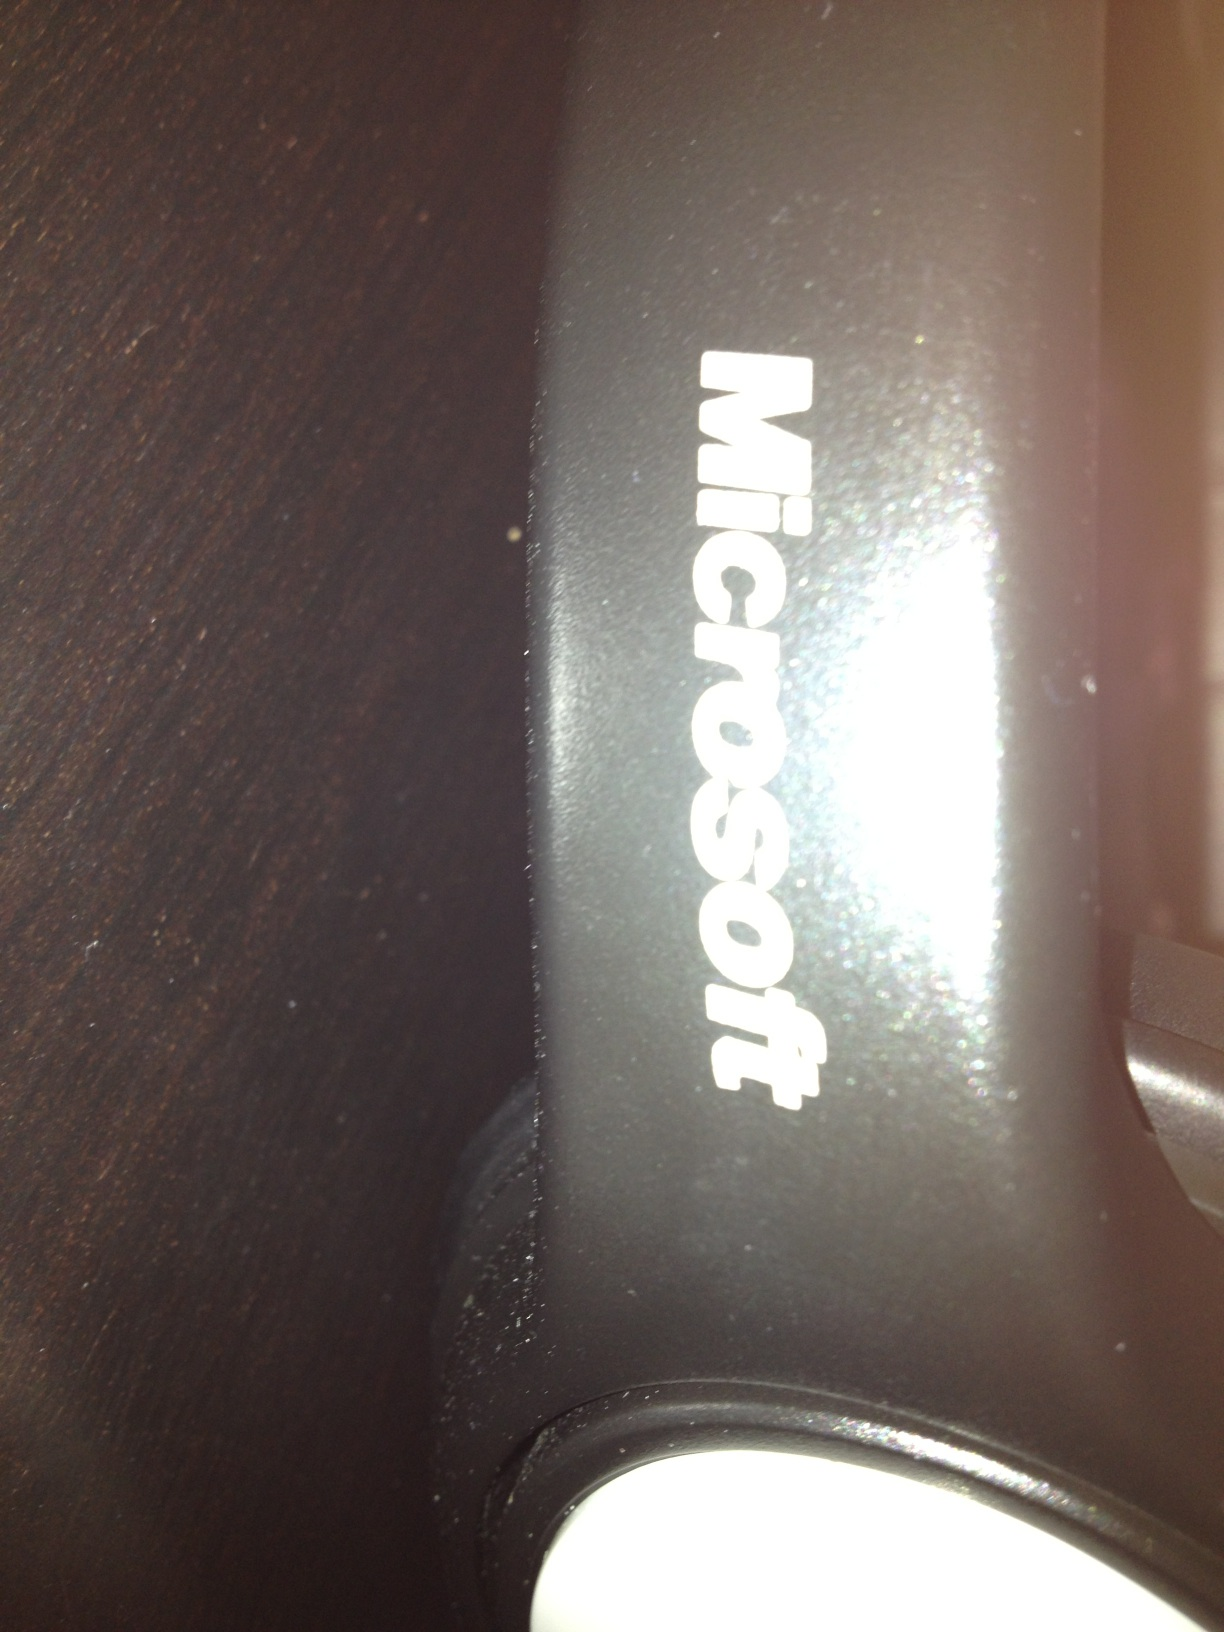Is there any wear or damage visible on the object that could indicate its age or usage? Yes, there are signs of wear and particles of dust visible on the surface, suggesting that the object has been used and could be relatively old. Could these signs of wear affect the functionality of the device? Normal wear and cosmetic damage, like scratches or dust, typically don't directly impact the functionality of electronic devices, unless there are deeper damages such as cracks or missing components. 